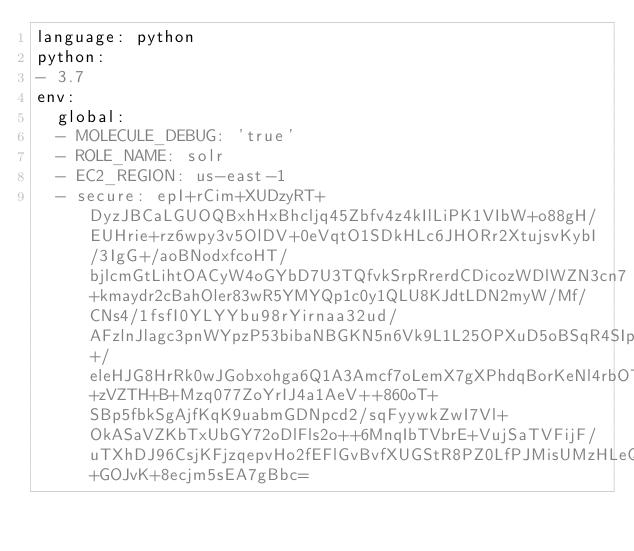Convert code to text. <code><loc_0><loc_0><loc_500><loc_500><_YAML_>language: python
python:
- 3.7
env:
  global:
  - MOLECULE_DEBUG: 'true'
  - ROLE_NAME: solr
  - EC2_REGION: us-east-1
  - secure: epI+rCim+XUDzyRT+DyzJBCaLGUOQBxhHxBhcljq45Zbfv4z4kIlLiPK1VIbW+o88gH/EUHrie+rz6wpy3v5OlDV+0eVqtO1SDkHLc6JHORr2XtujsvKybI/3IgG+/aoBNodxfcoHT/bjlcmGtLihtOACyW4oGYbD7U3TQfvkSrpRrerdCDicozWDlWZN3cn7+kmaydr2cBahOler83wR5YMYQp1c0y1QLU8KJdtLDN2myW/Mf/CNs4/1fsfI0YLYYbu98rYirnaa32ud/AFzlnJlagc3pnWYpzP53bibaNBGKN5n6Vk9L1L25OPXuD5oBSqR4SIpC3nvCs5TNIOBCrqDxqiDHq0xgE7ihM0ZC68vJUyFCQoNgD5yRC4f8VtOPhwdLn7nGJU7u65lOoIaHYpLc8cT7+/eleHJG8HrRk0wJGobxohga6Q1A3Amcf7oLemX7gXPhdqBorKeNl4rbOTYK+zVZTH+B+Mzq077ZoYrIJ4a1AeV++860oT+SBp5fbkSgAjfKqK9uabmGDNpcd2/sqFyywkZwI7Vl+OkASaVZKbTxUbGY72oDlFls2o++6MnqIbTVbrE+VujSaTVFijF/uTXhDJ96CsjKFjzqepvHo2fEFlGvBvfXUGStR8PZ0LfPJMisUMzHLeQ2nP7I+GOJvK+8ecjm5sEA7gBbc=</code> 